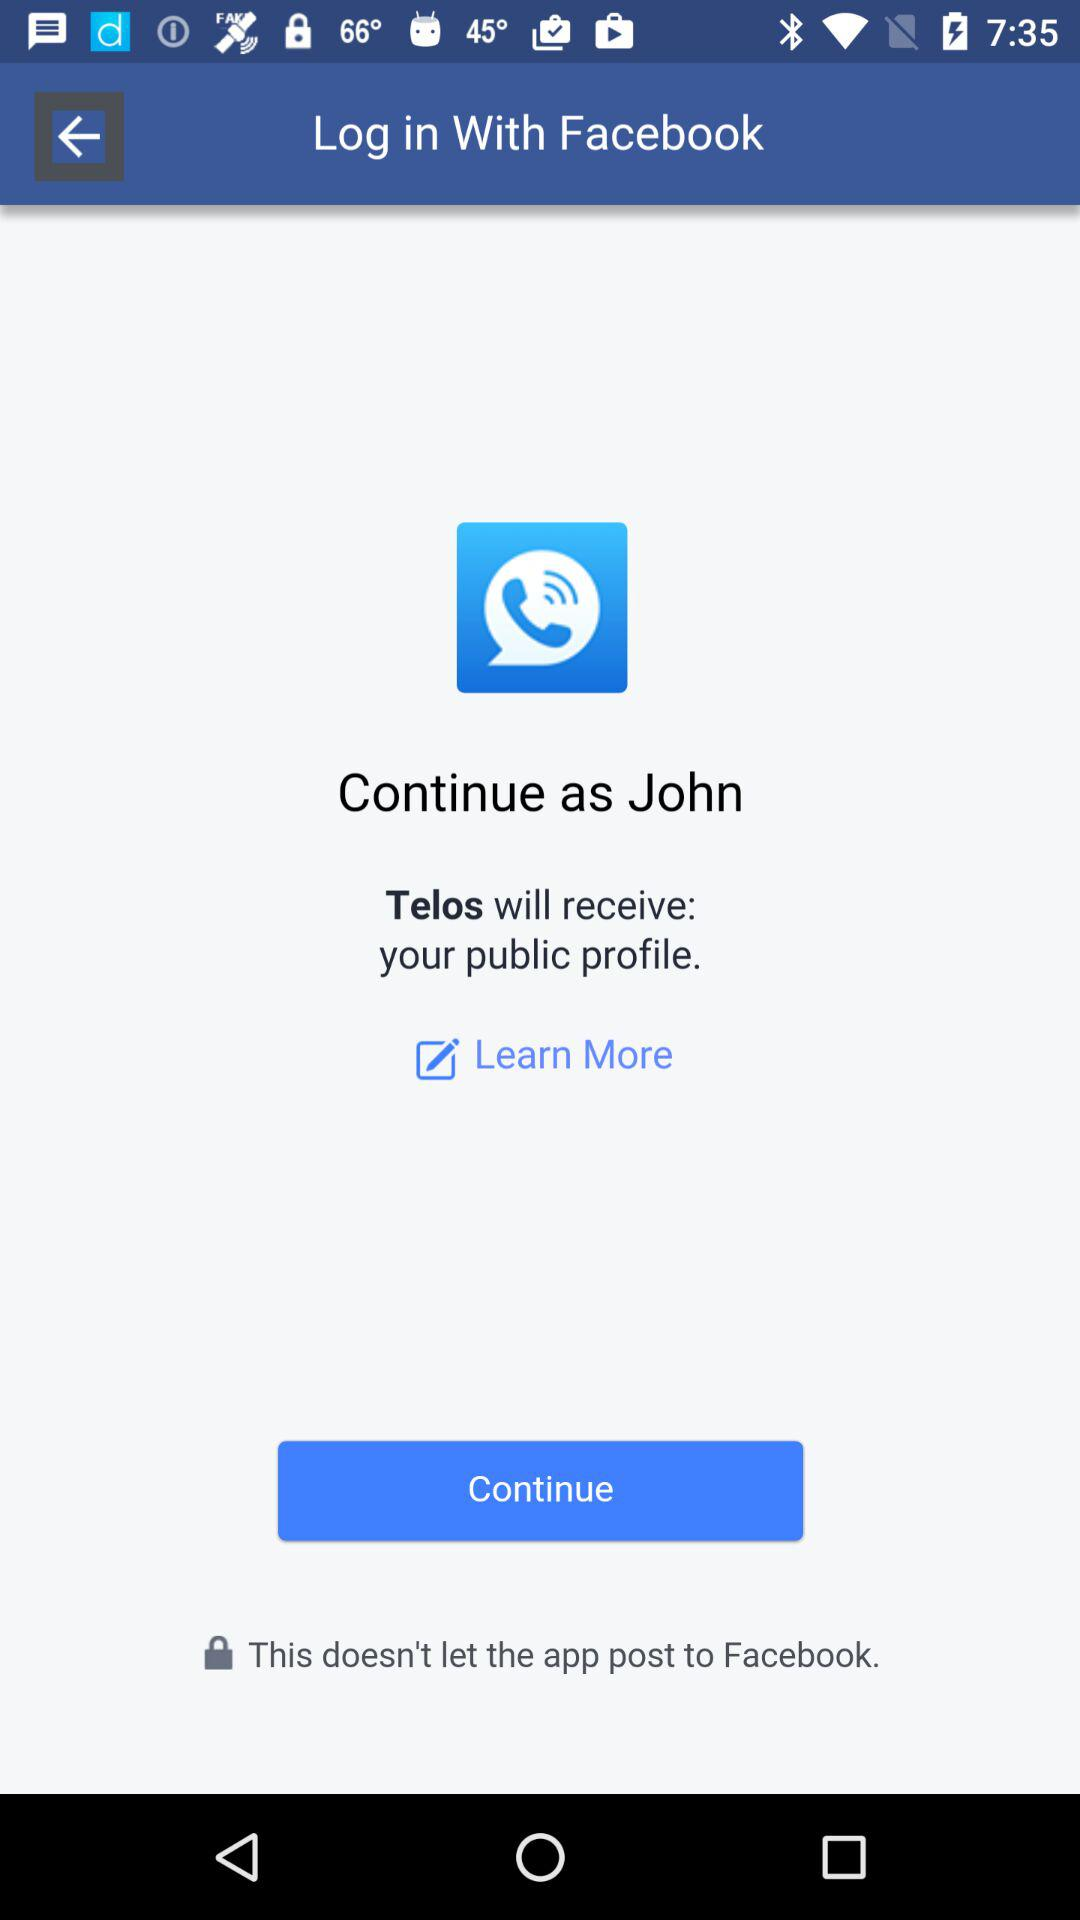What information will "Telos" receive? "Telos" will receive your public profile. 